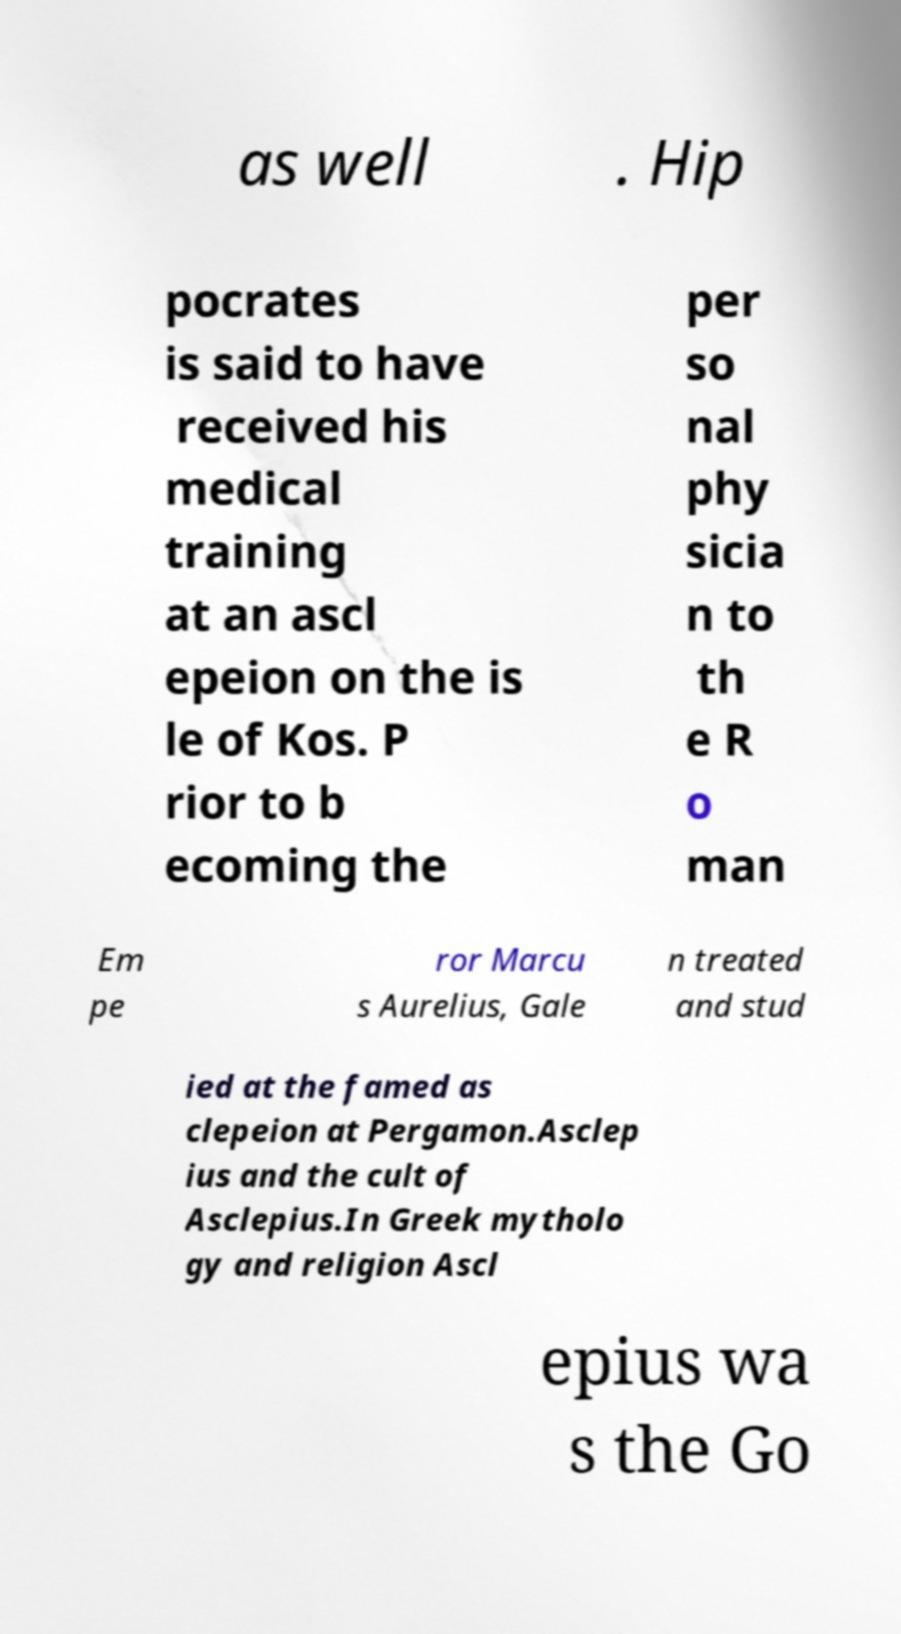For documentation purposes, I need the text within this image transcribed. Could you provide that? as well . Hip pocrates is said to have received his medical training at an ascl epeion on the is le of Kos. P rior to b ecoming the per so nal phy sicia n to th e R o man Em pe ror Marcu s Aurelius, Gale n treated and stud ied at the famed as clepeion at Pergamon.Asclep ius and the cult of Asclepius.In Greek mytholo gy and religion Ascl epius wa s the Go 